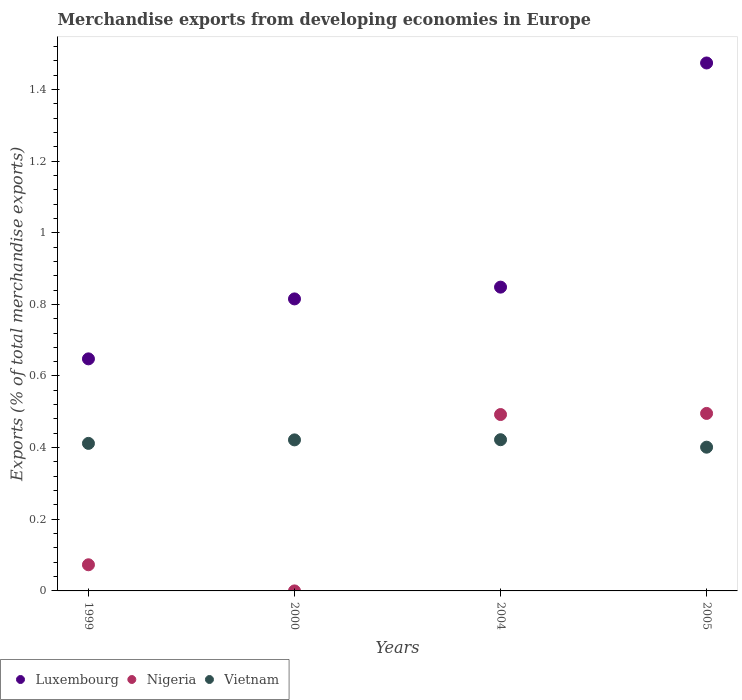Is the number of dotlines equal to the number of legend labels?
Offer a terse response. Yes. What is the percentage of total merchandise exports in Luxembourg in 2000?
Your response must be concise. 0.82. Across all years, what is the maximum percentage of total merchandise exports in Nigeria?
Provide a succinct answer. 0.5. Across all years, what is the minimum percentage of total merchandise exports in Vietnam?
Provide a succinct answer. 0.4. What is the total percentage of total merchandise exports in Nigeria in the graph?
Your answer should be compact. 1.06. What is the difference between the percentage of total merchandise exports in Vietnam in 2000 and that in 2004?
Ensure brevity in your answer.  -0. What is the difference between the percentage of total merchandise exports in Nigeria in 2004 and the percentage of total merchandise exports in Vietnam in 1999?
Make the answer very short. 0.08. What is the average percentage of total merchandise exports in Luxembourg per year?
Make the answer very short. 0.95. In the year 2004, what is the difference between the percentage of total merchandise exports in Luxembourg and percentage of total merchandise exports in Nigeria?
Give a very brief answer. 0.36. In how many years, is the percentage of total merchandise exports in Luxembourg greater than 0.7600000000000001 %?
Your answer should be compact. 3. What is the ratio of the percentage of total merchandise exports in Vietnam in 1999 to that in 2000?
Provide a short and direct response. 0.98. Is the percentage of total merchandise exports in Luxembourg in 2000 less than that in 2004?
Keep it short and to the point. Yes. Is the difference between the percentage of total merchandise exports in Luxembourg in 1999 and 2000 greater than the difference between the percentage of total merchandise exports in Nigeria in 1999 and 2000?
Your answer should be very brief. No. What is the difference between the highest and the second highest percentage of total merchandise exports in Nigeria?
Ensure brevity in your answer.  0. What is the difference between the highest and the lowest percentage of total merchandise exports in Nigeria?
Provide a short and direct response. 0.5. Is the sum of the percentage of total merchandise exports in Nigeria in 2000 and 2004 greater than the maximum percentage of total merchandise exports in Luxembourg across all years?
Provide a succinct answer. No. What is the difference between two consecutive major ticks on the Y-axis?
Your answer should be very brief. 0.2. Where does the legend appear in the graph?
Provide a succinct answer. Bottom left. How many legend labels are there?
Make the answer very short. 3. What is the title of the graph?
Provide a succinct answer. Merchandise exports from developing economies in Europe. Does "Slovak Republic" appear as one of the legend labels in the graph?
Keep it short and to the point. No. What is the label or title of the Y-axis?
Provide a short and direct response. Exports (% of total merchandise exports). What is the Exports (% of total merchandise exports) of Luxembourg in 1999?
Ensure brevity in your answer.  0.65. What is the Exports (% of total merchandise exports) in Nigeria in 1999?
Keep it short and to the point. 0.07. What is the Exports (% of total merchandise exports) of Vietnam in 1999?
Your answer should be very brief. 0.41. What is the Exports (% of total merchandise exports) in Luxembourg in 2000?
Your answer should be very brief. 0.82. What is the Exports (% of total merchandise exports) in Nigeria in 2000?
Provide a short and direct response. 3.88250814834461e-5. What is the Exports (% of total merchandise exports) in Vietnam in 2000?
Your answer should be compact. 0.42. What is the Exports (% of total merchandise exports) in Luxembourg in 2004?
Keep it short and to the point. 0.85. What is the Exports (% of total merchandise exports) of Nigeria in 2004?
Provide a short and direct response. 0.49. What is the Exports (% of total merchandise exports) of Vietnam in 2004?
Keep it short and to the point. 0.42. What is the Exports (% of total merchandise exports) of Luxembourg in 2005?
Give a very brief answer. 1.47. What is the Exports (% of total merchandise exports) of Nigeria in 2005?
Your response must be concise. 0.5. What is the Exports (% of total merchandise exports) in Vietnam in 2005?
Make the answer very short. 0.4. Across all years, what is the maximum Exports (% of total merchandise exports) of Luxembourg?
Ensure brevity in your answer.  1.47. Across all years, what is the maximum Exports (% of total merchandise exports) in Nigeria?
Ensure brevity in your answer.  0.5. Across all years, what is the maximum Exports (% of total merchandise exports) in Vietnam?
Provide a short and direct response. 0.42. Across all years, what is the minimum Exports (% of total merchandise exports) in Luxembourg?
Your answer should be compact. 0.65. Across all years, what is the minimum Exports (% of total merchandise exports) in Nigeria?
Provide a succinct answer. 3.88250814834461e-5. Across all years, what is the minimum Exports (% of total merchandise exports) of Vietnam?
Keep it short and to the point. 0.4. What is the total Exports (% of total merchandise exports) in Luxembourg in the graph?
Your answer should be very brief. 3.78. What is the total Exports (% of total merchandise exports) of Nigeria in the graph?
Make the answer very short. 1.06. What is the total Exports (% of total merchandise exports) in Vietnam in the graph?
Offer a terse response. 1.66. What is the difference between the Exports (% of total merchandise exports) in Luxembourg in 1999 and that in 2000?
Make the answer very short. -0.17. What is the difference between the Exports (% of total merchandise exports) in Nigeria in 1999 and that in 2000?
Give a very brief answer. 0.07. What is the difference between the Exports (% of total merchandise exports) of Vietnam in 1999 and that in 2000?
Offer a terse response. -0.01. What is the difference between the Exports (% of total merchandise exports) of Luxembourg in 1999 and that in 2004?
Offer a terse response. -0.2. What is the difference between the Exports (% of total merchandise exports) in Nigeria in 1999 and that in 2004?
Ensure brevity in your answer.  -0.42. What is the difference between the Exports (% of total merchandise exports) in Vietnam in 1999 and that in 2004?
Make the answer very short. -0.01. What is the difference between the Exports (% of total merchandise exports) of Luxembourg in 1999 and that in 2005?
Ensure brevity in your answer.  -0.83. What is the difference between the Exports (% of total merchandise exports) of Nigeria in 1999 and that in 2005?
Provide a short and direct response. -0.42. What is the difference between the Exports (% of total merchandise exports) in Vietnam in 1999 and that in 2005?
Offer a terse response. 0.01. What is the difference between the Exports (% of total merchandise exports) in Luxembourg in 2000 and that in 2004?
Offer a terse response. -0.03. What is the difference between the Exports (% of total merchandise exports) in Nigeria in 2000 and that in 2004?
Give a very brief answer. -0.49. What is the difference between the Exports (% of total merchandise exports) in Vietnam in 2000 and that in 2004?
Your response must be concise. -0. What is the difference between the Exports (% of total merchandise exports) in Luxembourg in 2000 and that in 2005?
Your answer should be compact. -0.66. What is the difference between the Exports (% of total merchandise exports) of Nigeria in 2000 and that in 2005?
Your response must be concise. -0.5. What is the difference between the Exports (% of total merchandise exports) in Vietnam in 2000 and that in 2005?
Give a very brief answer. 0.02. What is the difference between the Exports (% of total merchandise exports) of Luxembourg in 2004 and that in 2005?
Provide a short and direct response. -0.63. What is the difference between the Exports (% of total merchandise exports) in Nigeria in 2004 and that in 2005?
Your answer should be very brief. -0. What is the difference between the Exports (% of total merchandise exports) of Vietnam in 2004 and that in 2005?
Your answer should be compact. 0.02. What is the difference between the Exports (% of total merchandise exports) of Luxembourg in 1999 and the Exports (% of total merchandise exports) of Nigeria in 2000?
Your answer should be compact. 0.65. What is the difference between the Exports (% of total merchandise exports) of Luxembourg in 1999 and the Exports (% of total merchandise exports) of Vietnam in 2000?
Keep it short and to the point. 0.23. What is the difference between the Exports (% of total merchandise exports) of Nigeria in 1999 and the Exports (% of total merchandise exports) of Vietnam in 2000?
Your answer should be very brief. -0.35. What is the difference between the Exports (% of total merchandise exports) of Luxembourg in 1999 and the Exports (% of total merchandise exports) of Nigeria in 2004?
Make the answer very short. 0.16. What is the difference between the Exports (% of total merchandise exports) in Luxembourg in 1999 and the Exports (% of total merchandise exports) in Vietnam in 2004?
Your answer should be very brief. 0.23. What is the difference between the Exports (% of total merchandise exports) of Nigeria in 1999 and the Exports (% of total merchandise exports) of Vietnam in 2004?
Provide a short and direct response. -0.35. What is the difference between the Exports (% of total merchandise exports) in Luxembourg in 1999 and the Exports (% of total merchandise exports) in Nigeria in 2005?
Keep it short and to the point. 0.15. What is the difference between the Exports (% of total merchandise exports) in Luxembourg in 1999 and the Exports (% of total merchandise exports) in Vietnam in 2005?
Your response must be concise. 0.25. What is the difference between the Exports (% of total merchandise exports) in Nigeria in 1999 and the Exports (% of total merchandise exports) in Vietnam in 2005?
Offer a very short reply. -0.33. What is the difference between the Exports (% of total merchandise exports) of Luxembourg in 2000 and the Exports (% of total merchandise exports) of Nigeria in 2004?
Offer a very short reply. 0.32. What is the difference between the Exports (% of total merchandise exports) of Luxembourg in 2000 and the Exports (% of total merchandise exports) of Vietnam in 2004?
Ensure brevity in your answer.  0.39. What is the difference between the Exports (% of total merchandise exports) in Nigeria in 2000 and the Exports (% of total merchandise exports) in Vietnam in 2004?
Offer a terse response. -0.42. What is the difference between the Exports (% of total merchandise exports) in Luxembourg in 2000 and the Exports (% of total merchandise exports) in Nigeria in 2005?
Provide a succinct answer. 0.32. What is the difference between the Exports (% of total merchandise exports) of Luxembourg in 2000 and the Exports (% of total merchandise exports) of Vietnam in 2005?
Offer a terse response. 0.41. What is the difference between the Exports (% of total merchandise exports) in Nigeria in 2000 and the Exports (% of total merchandise exports) in Vietnam in 2005?
Your answer should be compact. -0.4. What is the difference between the Exports (% of total merchandise exports) of Luxembourg in 2004 and the Exports (% of total merchandise exports) of Nigeria in 2005?
Ensure brevity in your answer.  0.35. What is the difference between the Exports (% of total merchandise exports) in Luxembourg in 2004 and the Exports (% of total merchandise exports) in Vietnam in 2005?
Your answer should be very brief. 0.45. What is the difference between the Exports (% of total merchandise exports) of Nigeria in 2004 and the Exports (% of total merchandise exports) of Vietnam in 2005?
Give a very brief answer. 0.09. What is the average Exports (% of total merchandise exports) of Luxembourg per year?
Your answer should be very brief. 0.95. What is the average Exports (% of total merchandise exports) of Nigeria per year?
Give a very brief answer. 0.27. What is the average Exports (% of total merchandise exports) of Vietnam per year?
Your answer should be very brief. 0.41. In the year 1999, what is the difference between the Exports (% of total merchandise exports) in Luxembourg and Exports (% of total merchandise exports) in Nigeria?
Ensure brevity in your answer.  0.57. In the year 1999, what is the difference between the Exports (% of total merchandise exports) in Luxembourg and Exports (% of total merchandise exports) in Vietnam?
Keep it short and to the point. 0.24. In the year 1999, what is the difference between the Exports (% of total merchandise exports) of Nigeria and Exports (% of total merchandise exports) of Vietnam?
Ensure brevity in your answer.  -0.34. In the year 2000, what is the difference between the Exports (% of total merchandise exports) of Luxembourg and Exports (% of total merchandise exports) of Nigeria?
Ensure brevity in your answer.  0.82. In the year 2000, what is the difference between the Exports (% of total merchandise exports) in Luxembourg and Exports (% of total merchandise exports) in Vietnam?
Your answer should be very brief. 0.39. In the year 2000, what is the difference between the Exports (% of total merchandise exports) in Nigeria and Exports (% of total merchandise exports) in Vietnam?
Keep it short and to the point. -0.42. In the year 2004, what is the difference between the Exports (% of total merchandise exports) in Luxembourg and Exports (% of total merchandise exports) in Nigeria?
Your answer should be very brief. 0.36. In the year 2004, what is the difference between the Exports (% of total merchandise exports) of Luxembourg and Exports (% of total merchandise exports) of Vietnam?
Offer a very short reply. 0.43. In the year 2004, what is the difference between the Exports (% of total merchandise exports) in Nigeria and Exports (% of total merchandise exports) in Vietnam?
Provide a succinct answer. 0.07. In the year 2005, what is the difference between the Exports (% of total merchandise exports) of Luxembourg and Exports (% of total merchandise exports) of Nigeria?
Your response must be concise. 0.98. In the year 2005, what is the difference between the Exports (% of total merchandise exports) of Luxembourg and Exports (% of total merchandise exports) of Vietnam?
Provide a succinct answer. 1.07. In the year 2005, what is the difference between the Exports (% of total merchandise exports) of Nigeria and Exports (% of total merchandise exports) of Vietnam?
Make the answer very short. 0.09. What is the ratio of the Exports (% of total merchandise exports) in Luxembourg in 1999 to that in 2000?
Offer a very short reply. 0.79. What is the ratio of the Exports (% of total merchandise exports) in Nigeria in 1999 to that in 2000?
Provide a succinct answer. 1879.81. What is the ratio of the Exports (% of total merchandise exports) in Vietnam in 1999 to that in 2000?
Provide a short and direct response. 0.98. What is the ratio of the Exports (% of total merchandise exports) of Luxembourg in 1999 to that in 2004?
Provide a short and direct response. 0.76. What is the ratio of the Exports (% of total merchandise exports) in Nigeria in 1999 to that in 2004?
Your answer should be compact. 0.15. What is the ratio of the Exports (% of total merchandise exports) in Vietnam in 1999 to that in 2004?
Give a very brief answer. 0.98. What is the ratio of the Exports (% of total merchandise exports) in Luxembourg in 1999 to that in 2005?
Provide a short and direct response. 0.44. What is the ratio of the Exports (% of total merchandise exports) of Nigeria in 1999 to that in 2005?
Keep it short and to the point. 0.15. What is the ratio of the Exports (% of total merchandise exports) in Vietnam in 1999 to that in 2005?
Your answer should be very brief. 1.03. What is the ratio of the Exports (% of total merchandise exports) in Luxembourg in 2000 to that in 2004?
Provide a short and direct response. 0.96. What is the ratio of the Exports (% of total merchandise exports) of Luxembourg in 2000 to that in 2005?
Make the answer very short. 0.55. What is the ratio of the Exports (% of total merchandise exports) in Nigeria in 2000 to that in 2005?
Make the answer very short. 0. What is the ratio of the Exports (% of total merchandise exports) of Vietnam in 2000 to that in 2005?
Your answer should be compact. 1.05. What is the ratio of the Exports (% of total merchandise exports) of Luxembourg in 2004 to that in 2005?
Give a very brief answer. 0.58. What is the ratio of the Exports (% of total merchandise exports) of Nigeria in 2004 to that in 2005?
Give a very brief answer. 0.99. What is the ratio of the Exports (% of total merchandise exports) in Vietnam in 2004 to that in 2005?
Make the answer very short. 1.05. What is the difference between the highest and the second highest Exports (% of total merchandise exports) of Luxembourg?
Give a very brief answer. 0.63. What is the difference between the highest and the second highest Exports (% of total merchandise exports) of Nigeria?
Provide a succinct answer. 0. What is the difference between the highest and the second highest Exports (% of total merchandise exports) of Vietnam?
Offer a terse response. 0. What is the difference between the highest and the lowest Exports (% of total merchandise exports) of Luxembourg?
Offer a terse response. 0.83. What is the difference between the highest and the lowest Exports (% of total merchandise exports) in Nigeria?
Ensure brevity in your answer.  0.5. What is the difference between the highest and the lowest Exports (% of total merchandise exports) of Vietnam?
Keep it short and to the point. 0.02. 